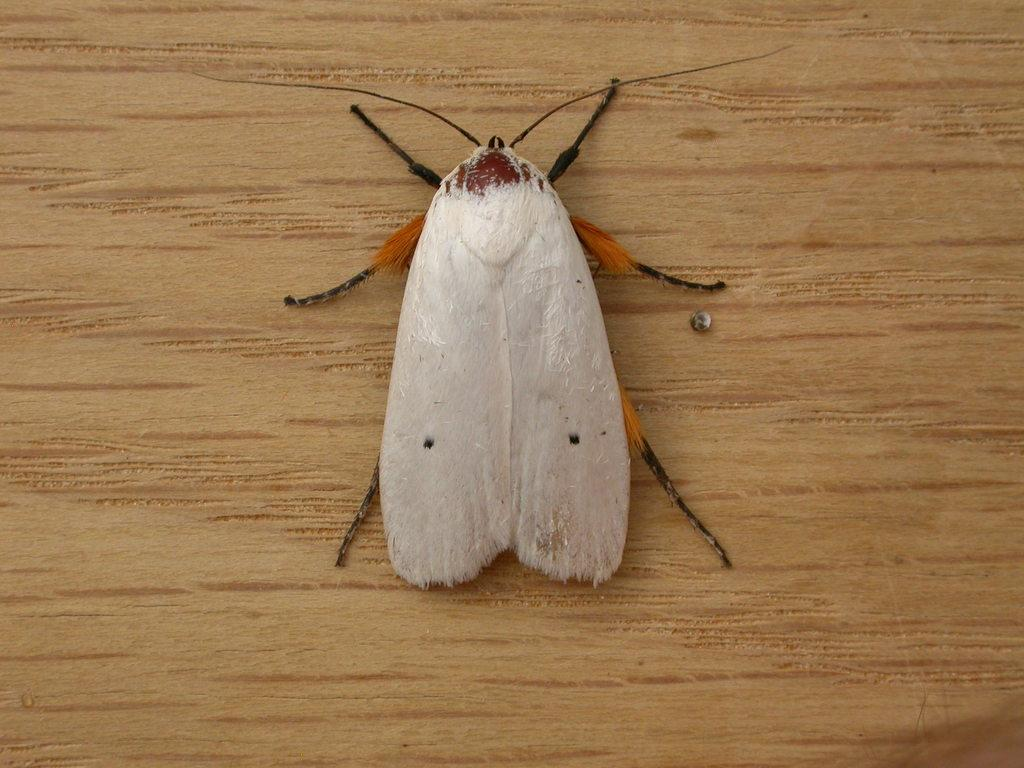What type of creature can be seen in the image? There is an insect in the image. What is the insect resting on in the image? The insect is on a wooden surface. What type of sound can be heard coming from the insect in the image? There is no sound coming from the insect in the image, as insects do not produce sound that can be heard in a still image. 